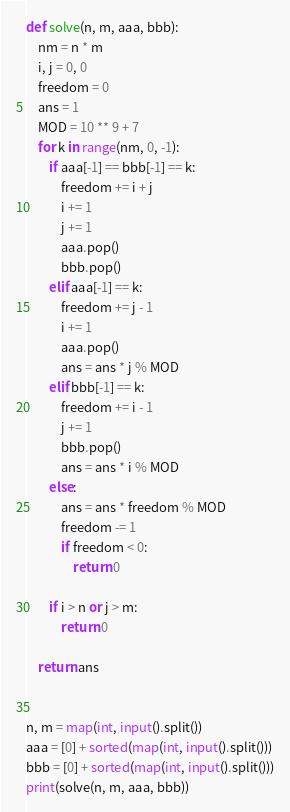<code> <loc_0><loc_0><loc_500><loc_500><_Python_>def solve(n, m, aaa, bbb):
    nm = n * m
    i, j = 0, 0
    freedom = 0
    ans = 1
    MOD = 10 ** 9 + 7
    for k in range(nm, 0, -1):
        if aaa[-1] == bbb[-1] == k:
            freedom += i + j
            i += 1
            j += 1
            aaa.pop()
            bbb.pop()
        elif aaa[-1] == k:
            freedom += j - 1
            i += 1
            aaa.pop()
            ans = ans * j % MOD
        elif bbb[-1] == k:
            freedom += i - 1
            j += 1
            bbb.pop()
            ans = ans * i % MOD
        else:
            ans = ans * freedom % MOD
            freedom -= 1
            if freedom < 0:
                return 0

        if i > n or j > m:
            return 0

    return ans


n, m = map(int, input().split())
aaa = [0] + sorted(map(int, input().split()))
bbb = [0] + sorted(map(int, input().split()))
print(solve(n, m, aaa, bbb))
</code> 